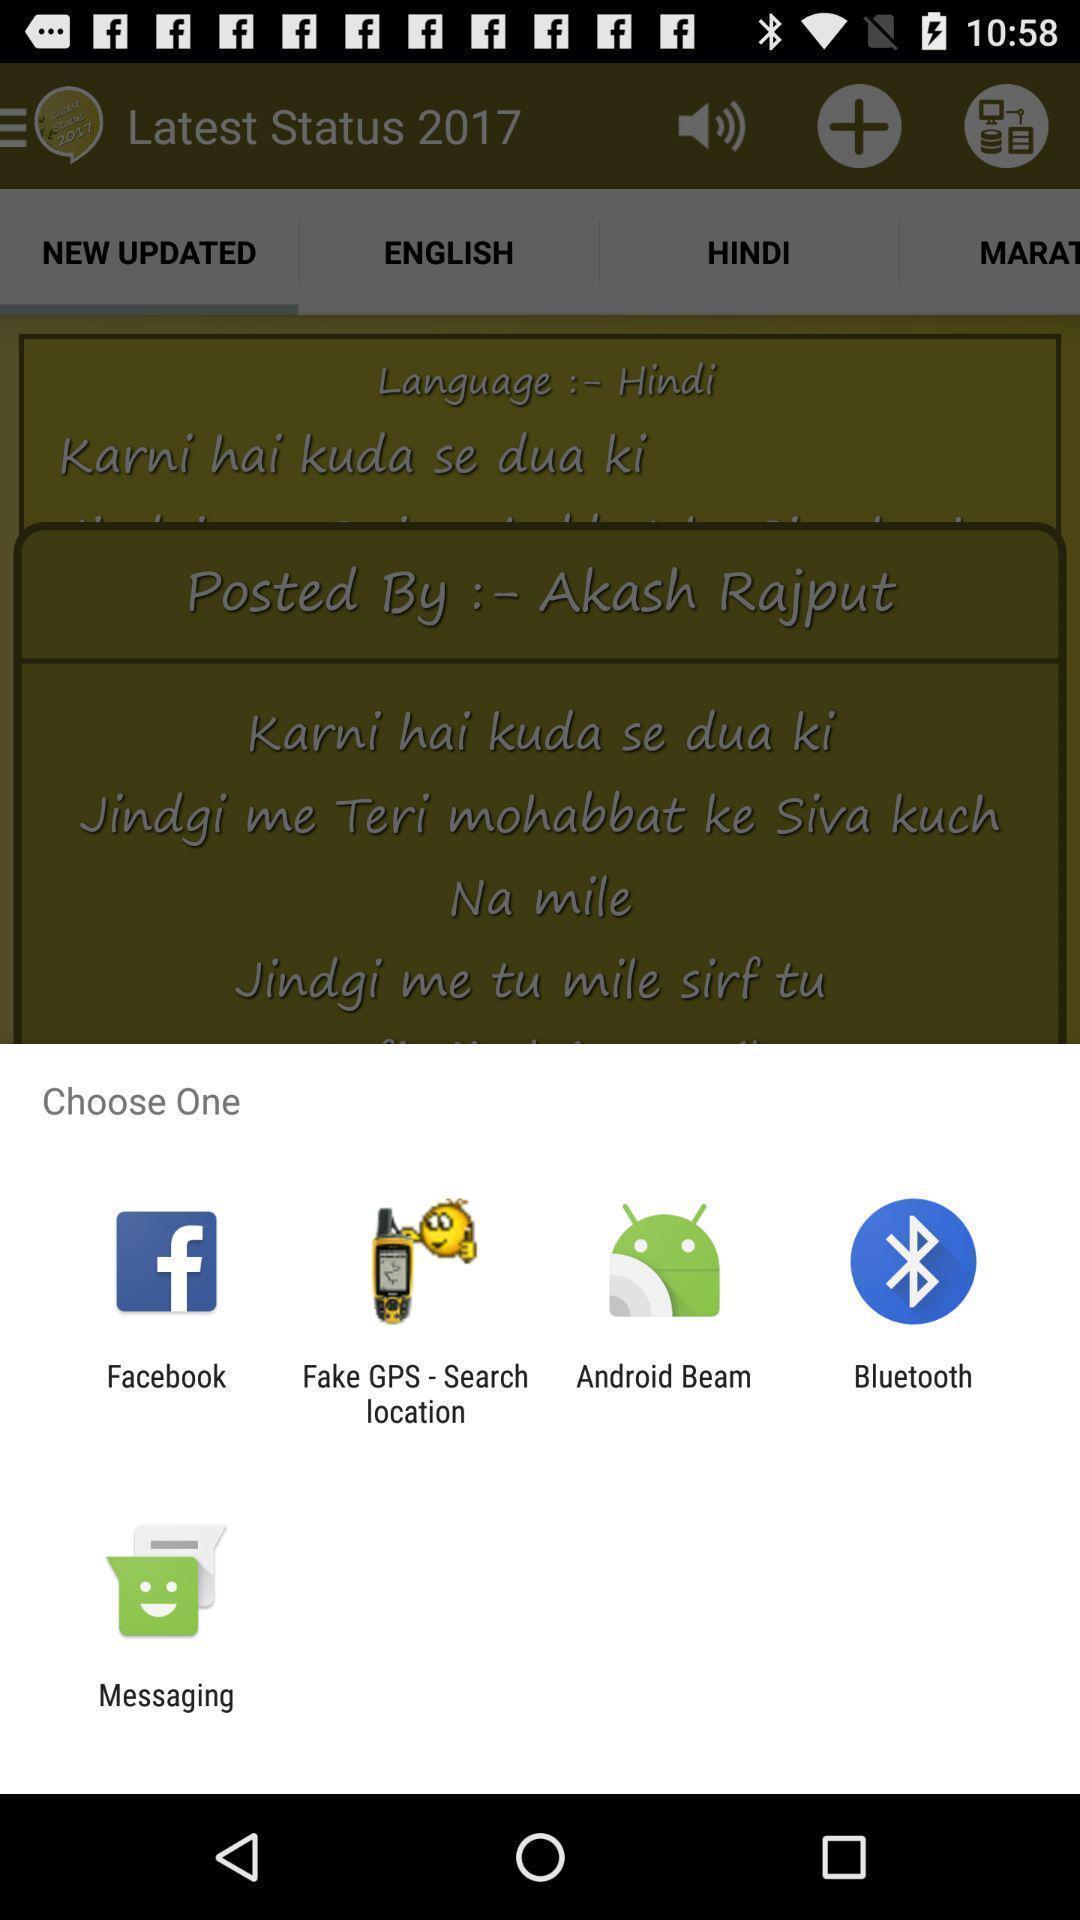Describe the key features of this screenshot. Pop up showing various apps. 